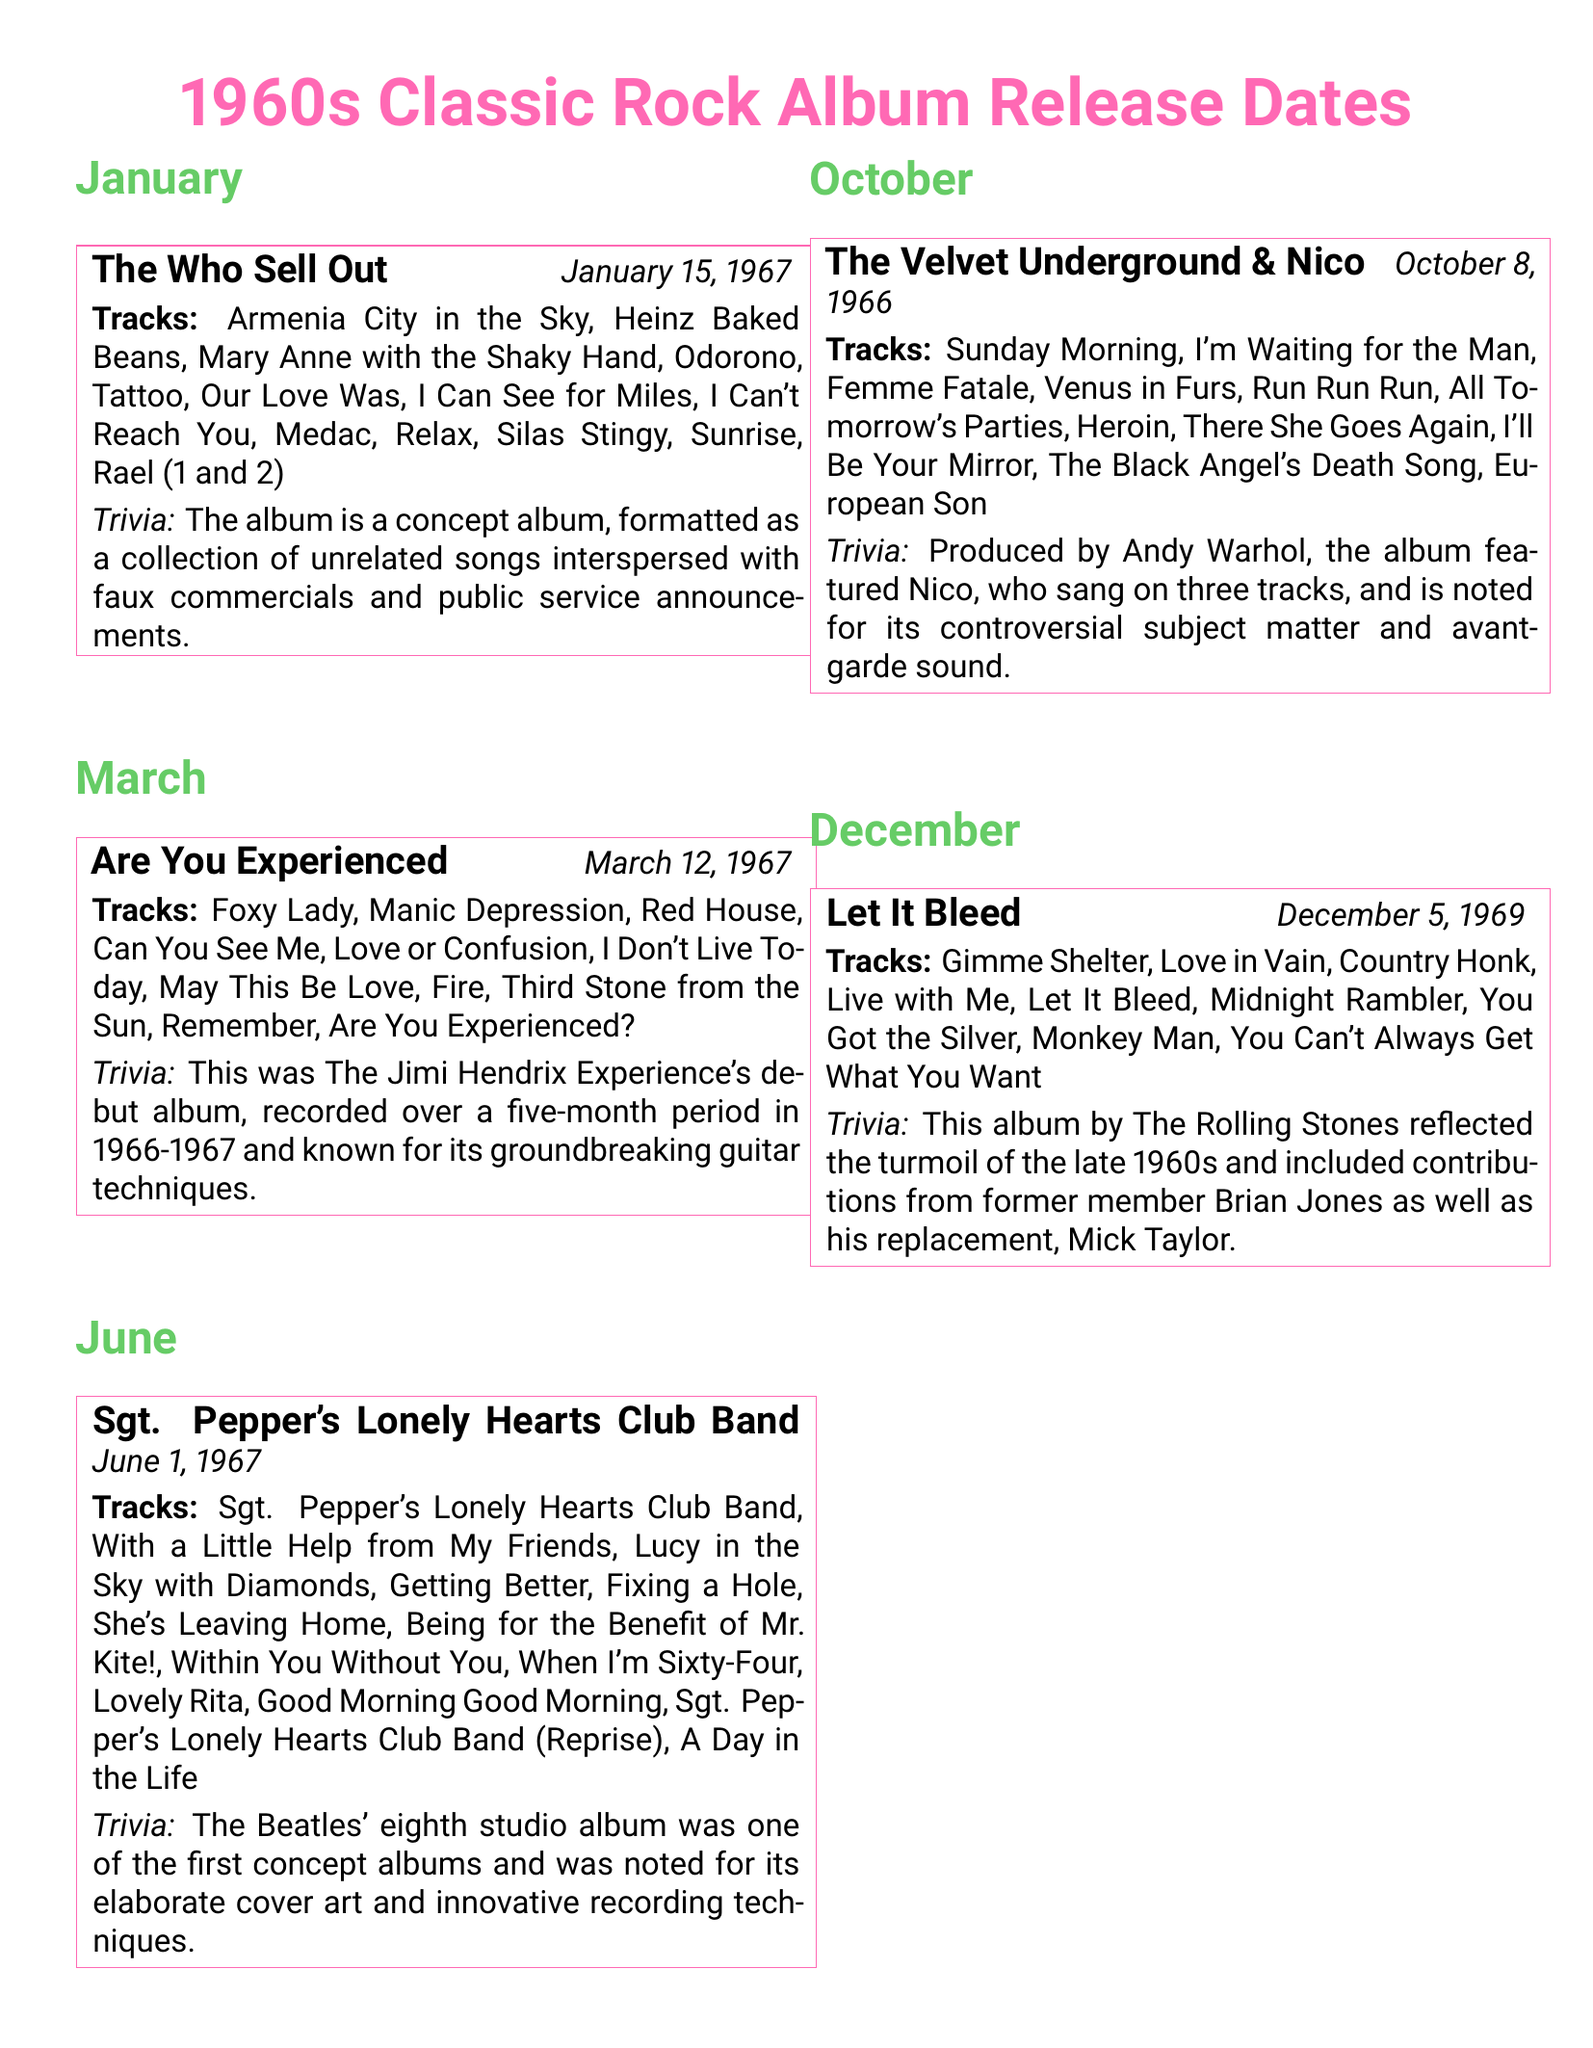What is the release date of "The Who Sell Out"? The release date of "The Who Sell Out" is mentioned in the document as January 15, 1967.
Answer: January 15, 1967 How many tracks are listed for "Are You Experienced"? The document shows a total of 11 tracks listed for "Are You Experienced."
Answer: 11 tracks What is the name of the last track on "Sgt. Pepper's Lonely Hearts Club Band"? The last track of the album "Sgt. Pepper's Lonely Hearts Club Band" is "A Day in the Life."
Answer: A Day in the Life Which band's debut album is "Are You Experienced"? The document indicates that "Are You Experienced" is the debut album of The Jimi Hendrix Experience.
Answer: The Jimi Hendrix Experience What notable feature does "The Velvet Underground & Nico" have related to its production? The document notes that the album was produced by Andy Warhol.
Answer: Andy Warhol What theme does "Let It Bleed" reflect? The document describes that "Let It Bleed" reflects the turmoil of the late 1960s.
Answer: Turmoil of the late 1960s How many albums are listed in the document? The document lists a total of 5 albums in the calendar.
Answer: 5 albums Which album features the track "Lucy in the Sky with Diamonds"? The document specifies that "Lucy in the Sky with Diamonds" is a track on "Sgt. Pepper's Lonely Hearts Club Band."
Answer: Sgt. Pepper's Lonely Hearts Club Band What was innovative about the recording techniques of "Sgt. Pepper's Lonely Hearts Club Band"? The document refers to the album being noted for its innovative recording techniques.
Answer: Innovative recording techniques 